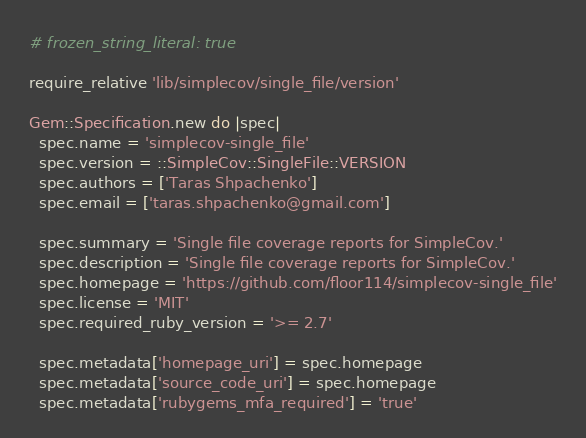Convert code to text. <code><loc_0><loc_0><loc_500><loc_500><_Ruby_># frozen_string_literal: true

require_relative 'lib/simplecov/single_file/version'

Gem::Specification.new do |spec|
  spec.name = 'simplecov-single_file'
  spec.version = ::SimpleCov::SingleFile::VERSION
  spec.authors = ['Taras Shpachenko']
  spec.email = ['taras.shpachenko@gmail.com']

  spec.summary = 'Single file coverage reports for SimpleCov.'
  spec.description = 'Single file coverage reports for SimpleCov.'
  spec.homepage = 'https://github.com/floor114/simplecov-single_file'
  spec.license = 'MIT'
  spec.required_ruby_version = '>= 2.7'

  spec.metadata['homepage_uri'] = spec.homepage
  spec.metadata['source_code_uri'] = spec.homepage
  spec.metadata['rubygems_mfa_required'] = 'true'
</code> 